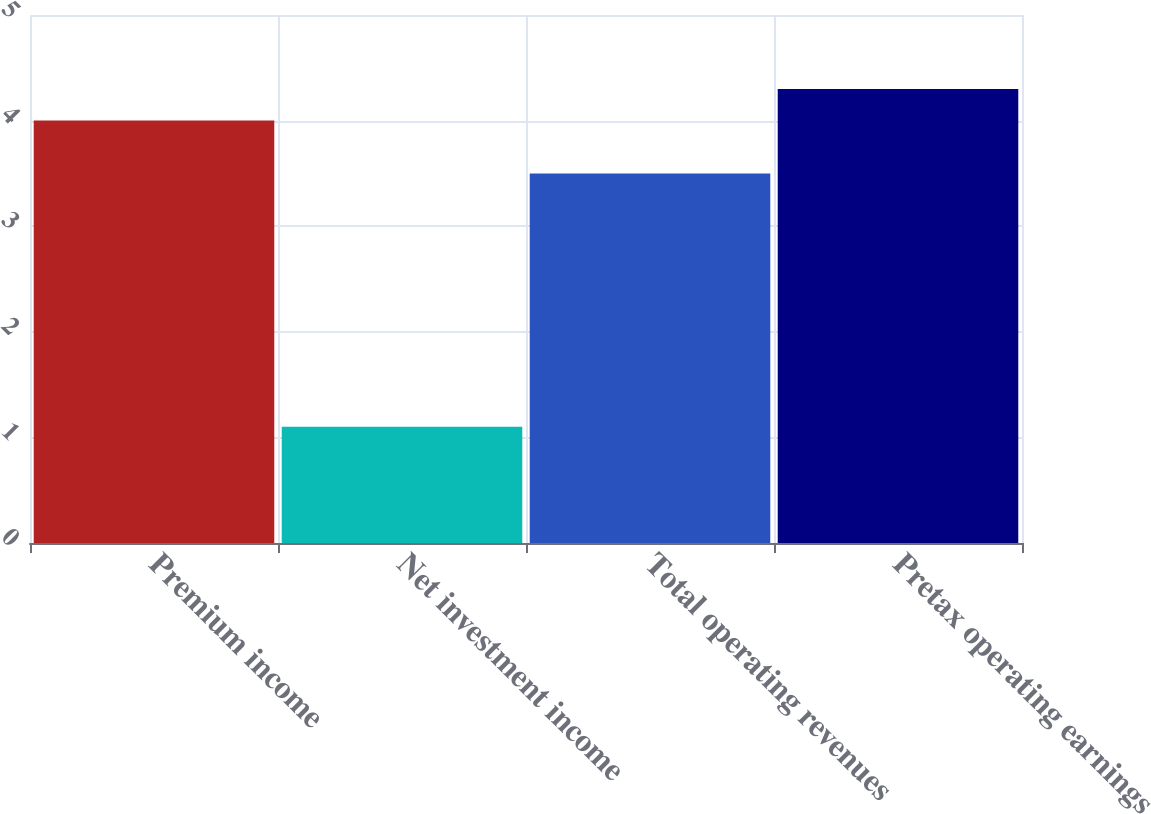Convert chart to OTSL. <chart><loc_0><loc_0><loc_500><loc_500><bar_chart><fcel>Premium income<fcel>Net investment income<fcel>Total operating revenues<fcel>Pretax operating earnings<nl><fcel>4<fcel>1.1<fcel>3.5<fcel>4.3<nl></chart> 